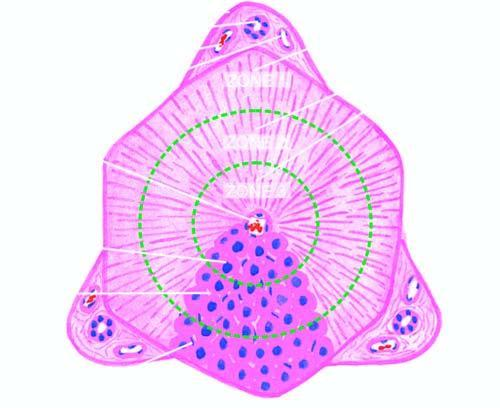re the functional divisions of the lobule into 3 zones shown by circles?
Answer the question using a single word or phrase. Yes 